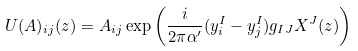Convert formula to latex. <formula><loc_0><loc_0><loc_500><loc_500>U ( A ) _ { i j } ( z ) = A _ { i j } \exp \left ( \frac { i } { 2 \pi \alpha ^ { \prime } } ( y ^ { I } _ { i } - y ^ { I } _ { j } ) g _ { I J } X ^ { J } ( z ) \right ) \</formula> 